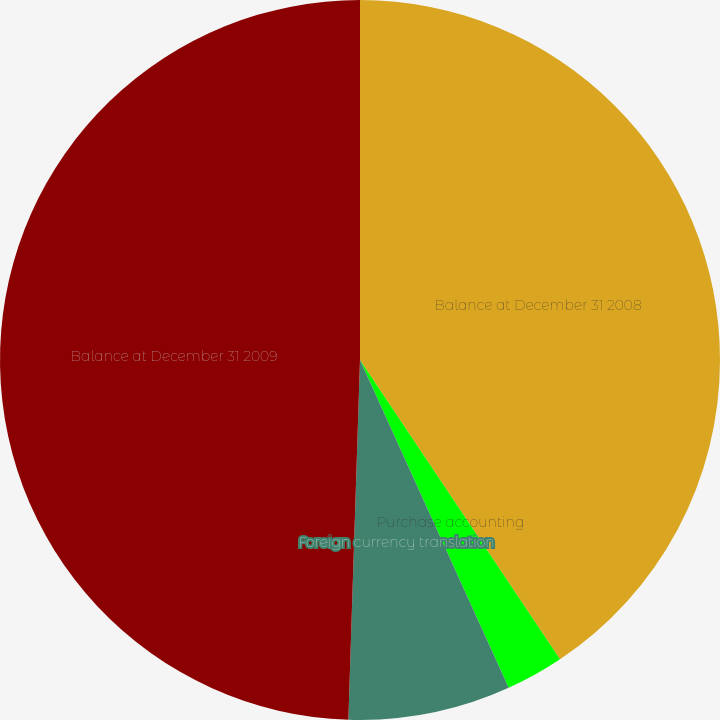<chart> <loc_0><loc_0><loc_500><loc_500><pie_chart><fcel>Balance at December 31 2008<fcel>Purchase accounting<fcel>Foreign currency translation<fcel>Balance at December 31 2009<nl><fcel>40.62%<fcel>2.6%<fcel>7.29%<fcel>49.48%<nl></chart> 